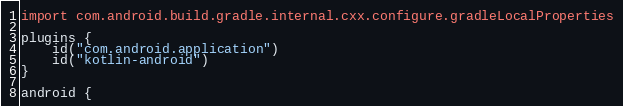<code> <loc_0><loc_0><loc_500><loc_500><_Kotlin_>import com.android.build.gradle.internal.cxx.configure.gradleLocalProperties

plugins {
    id("com.android.application")
    id("kotlin-android")
}

android {</code> 